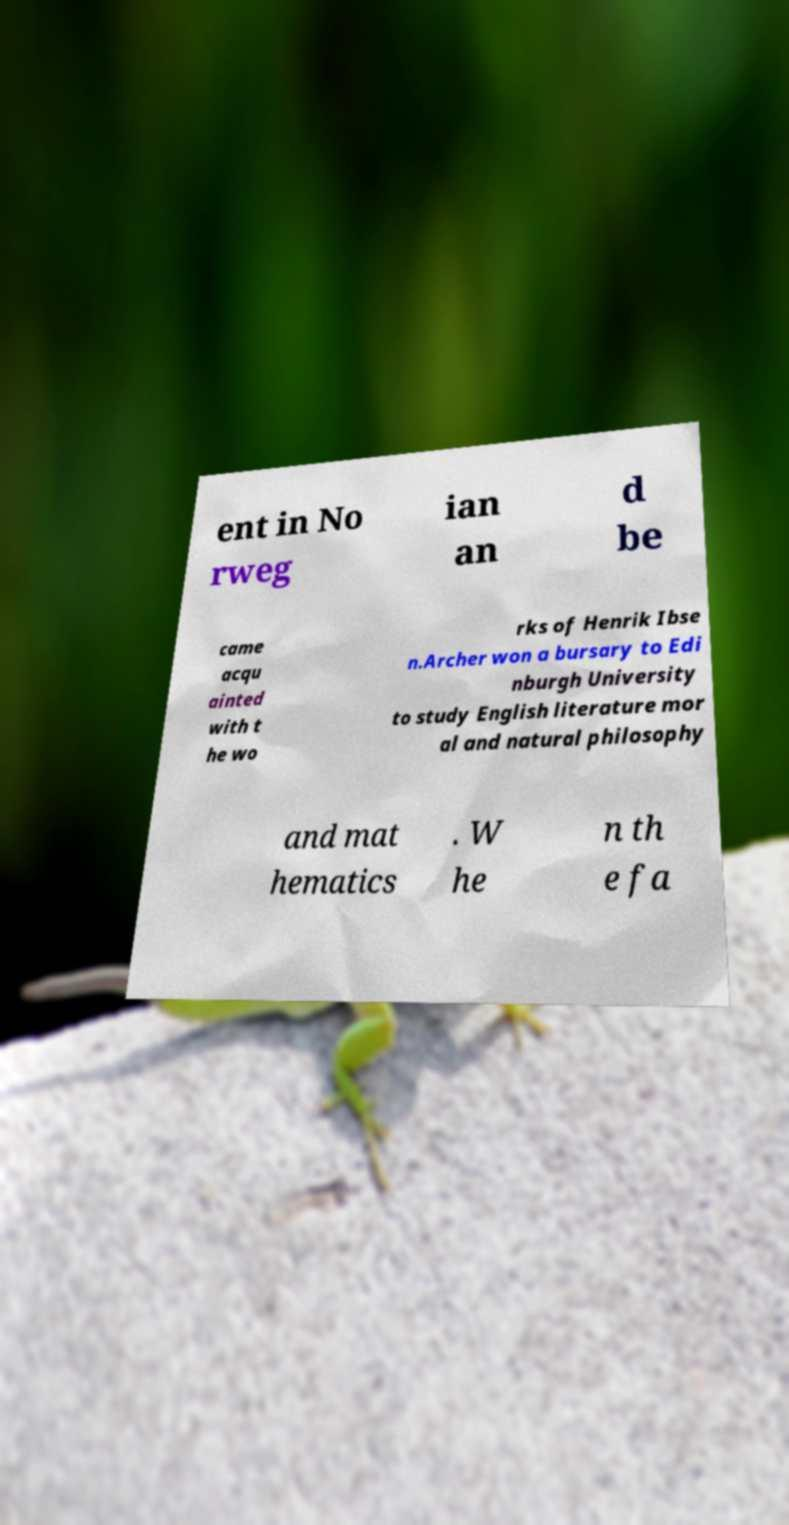There's text embedded in this image that I need extracted. Can you transcribe it verbatim? ent in No rweg ian an d be came acqu ainted with t he wo rks of Henrik Ibse n.Archer won a bursary to Edi nburgh University to study English literature mor al and natural philosophy and mat hematics . W he n th e fa 